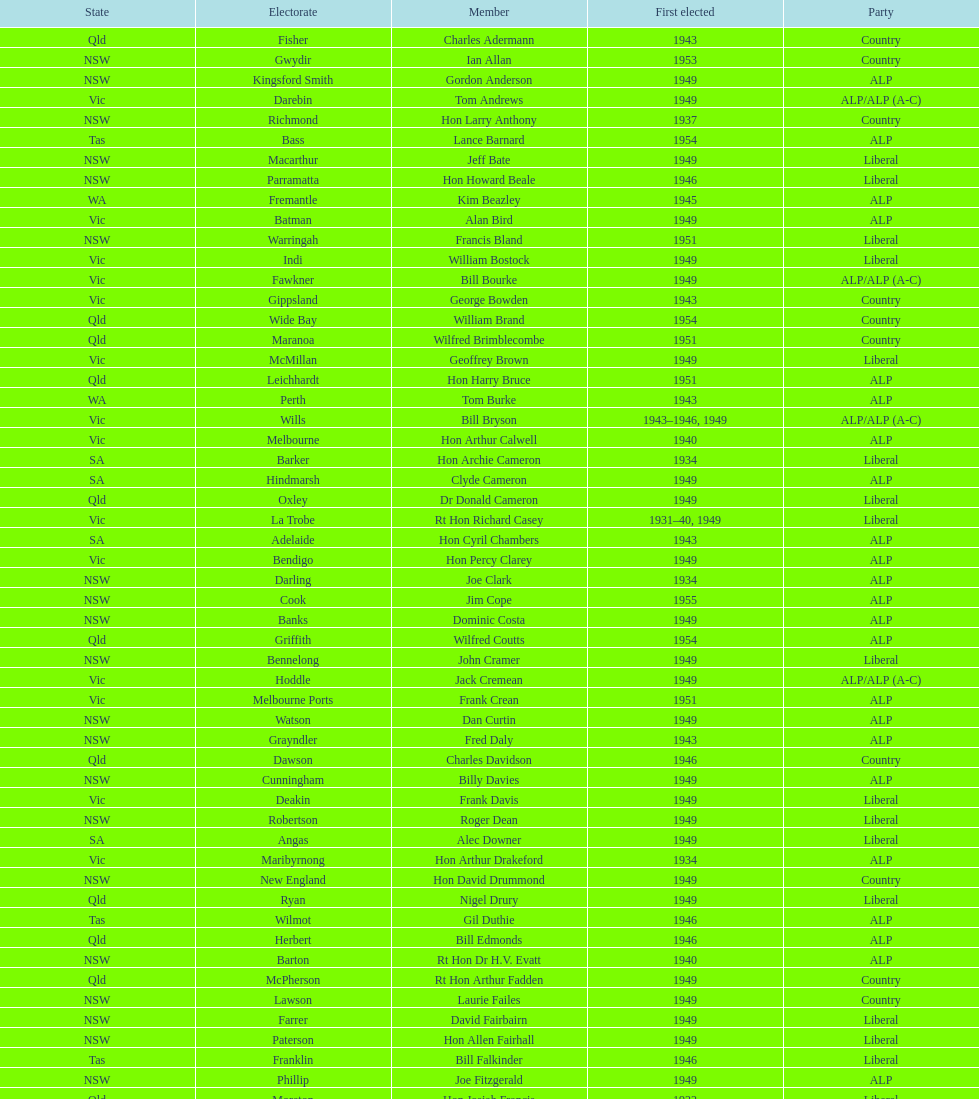Which party was elected the least? Country. 